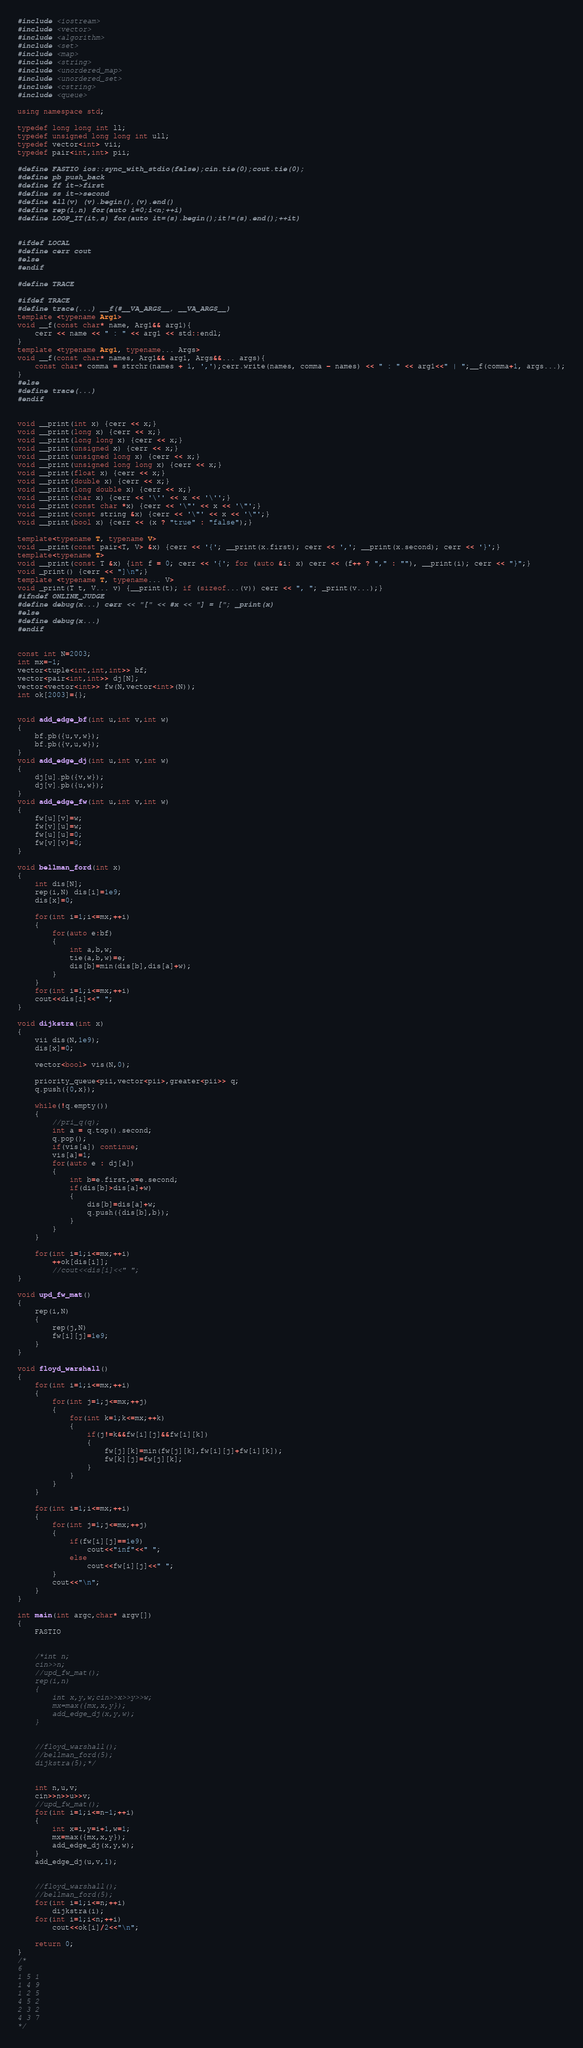<code> <loc_0><loc_0><loc_500><loc_500><_C++_>#include <iostream>
#include <vector>
#include <algorithm>
#include <set>
#include <map>
#include <string>
#include <unordered_map>
#include <unordered_set>
#include <cstring>
#include <queue>

using namespace std;

typedef long long int ll;
typedef unsigned long long int ull;
typedef vector<int> vii;
typedef pair<int,int> pii;

#define FASTIO ios::sync_with_stdio(false);cin.tie(0);cout.tie(0);
#define pb push_back
#define ff it->first
#define ss it->second
#define all(v) (v).begin(),(v).end()
#define rep(i,n) for(auto i=0;i<n;++i)
#define LOOP_IT(it,s) for(auto it=(s).begin();it!=(s).end();++it)


#ifdef LOCAL
#define cerr cout
#else
#endif

#define TRACE

#ifdef TRACE
#define trace(...) __f(#__VA_ARGS__, __VA_ARGS__)
template <typename Arg1>
void __f(const char* name, Arg1&& arg1){
	cerr << name << " : " << arg1 << std::endl;
}
template <typename Arg1, typename... Args>
void __f(const char* names, Arg1&& arg1, Args&&... args){
	const char* comma = strchr(names + 1, ',');cerr.write(names, comma - names) << " : " << arg1<<" | ";__f(comma+1, args...);
}
#else
#define trace(...)
#endif


void __print(int x) {cerr << x;}
void __print(long x) {cerr << x;}
void __print(long long x) {cerr << x;}
void __print(unsigned x) {cerr << x;}
void __print(unsigned long x) {cerr << x;}
void __print(unsigned long long x) {cerr << x;}
void __print(float x) {cerr << x;}
void __print(double x) {cerr << x;}
void __print(long double x) {cerr << x;}
void __print(char x) {cerr << '\'' << x << '\'';}
void __print(const char *x) {cerr << '\"' << x << '\"';}
void __print(const string &x) {cerr << '\"' << x << '\"';}
void __print(bool x) {cerr << (x ? "true" : "false");}

template<typename T, typename V>
void __print(const pair<T, V> &x) {cerr << '{'; __print(x.first); cerr << ','; __print(x.second); cerr << '}';}
template<typename T>
void __print(const T &x) {int f = 0; cerr << '{'; for (auto &i: x) cerr << (f++ ? "," : ""), __print(i); cerr << "}";}
void _print() {cerr << "]\n";}
template <typename T, typename... V>
void _print(T t, V... v) {__print(t); if (sizeof...(v)) cerr << ", "; _print(v...);}
#ifndef ONLINE_JUDGE
#define debug(x...) cerr << "[" << #x << "] = ["; _print(x)
#else
#define debug(x...)
#endif


const int N=2003;
int mx=-1;
vector<tuple<int,int,int>> bf;
vector<pair<int,int>> dj[N];
vector<vector<int>> fw(N,vector<int>(N));
int ok[2003]={};


void add_edge_bf(int u,int v,int w)
{
    bf.pb({u,v,w});
    bf.pb({v,u,w});
}
void add_edge_dj(int u,int v,int w)
{
    dj[u].pb({v,w});
    dj[v].pb({u,w});
}
void add_edge_fw(int u,int v,int w)
{
    fw[u][v]=w;
    fw[v][u]=w;
    fw[u][u]=0;
    fw[v][v]=0;
}

void bellman_ford(int x)
{
    int dis[N];
    rep(i,N) dis[i]=1e9;
    dis[x]=0;

    for(int i=1;i<=mx;++i)
    {
        for(auto e:bf)
        {
            int a,b,w;
            tie(a,b,w)=e;
            dis[b]=min(dis[b],dis[a]+w);
        }
    }
    for(int i=1;i<=mx;++i)
    cout<<dis[i]<<" ";
}

void dijkstra(int x)
{
    vii dis(N,1e9);
    dis[x]=0;

    vector<bool> vis(N,0);

    priority_queue<pii,vector<pii>,greater<pii>> q;
    q.push({0,x});

    while(!q.empty())
    {
        //pri_q(q);
        int a = q.top().second;
        q.pop();
        if(vis[a]) continue;
        vis[a]=1;
        for(auto e : dj[a])
        {
            int b=e.first,w=e.second;
            if(dis[b]>dis[a]+w)
            {
                dis[b]=dis[a]+w;
                q.push({dis[b],b});
            }
        }
    }

    for(int i=1;i<=mx;++i)
        ++ok[dis[i]];
        //cout<<dis[i]<<" ";
}

void upd_fw_mat()
{
    rep(i,N)
    {
        rep(j,N)
        fw[i][j]=1e9;
    }
}

void floyd_warshall()
{
    for(int i=1;i<=mx;++i)
    {
        for(int j=1;j<=mx;++j)
        {
            for(int k=1;k<=mx;++k)
            {
                if(j!=k&&fw[i][j]&&fw[i][k])
                {
                    fw[j][k]=min(fw[j][k],fw[i][j]+fw[i][k]);
                    fw[k][j]=fw[j][k];
                }
            }
        }
    }

    for(int i=1;i<=mx;++i)
    {
        for(int j=1;j<=mx;++j)
        {
            if(fw[i][j]==1e9)
                cout<<"inf"<<" ";
            else
                cout<<fw[i][j]<<" ";
        }
        cout<<"\n";
    }
}

int main(int argc,char* argv[])
{
    FASTIO


    /*int n;
    cin>>n;
    //upd_fw_mat();
    rep(i,n)
    {
        int x,y,w;cin>>x>>y>>w;
        mx=max({mx,x,y});
        add_edge_dj(x,y,w);
    }


    //floyd_warshall();
    //bellman_ford(5);
    dijkstra(5);*/


    int n,u,v;
    cin>>n>>u>>v;
    //upd_fw_mat();
    for(int i=1;i<=n-1;++i)
    {
        int x=i,y=i+1,w=1;
        mx=max({mx,x,y});
        add_edge_dj(x,y,w);
    }
    add_edge_dj(u,v,1);


    //floyd_warshall();
    //bellman_ford(5);
    for(int i=1;i<=n;++i)
        dijkstra(i);
    for(int i=1;i<n;++i)
        cout<<ok[i]/2<<"\n";

    return 0;
}
/*
6
1 5 1
1 4 9
1 2 5
4 5 2
2 3 2
4 3 7
*/
</code> 